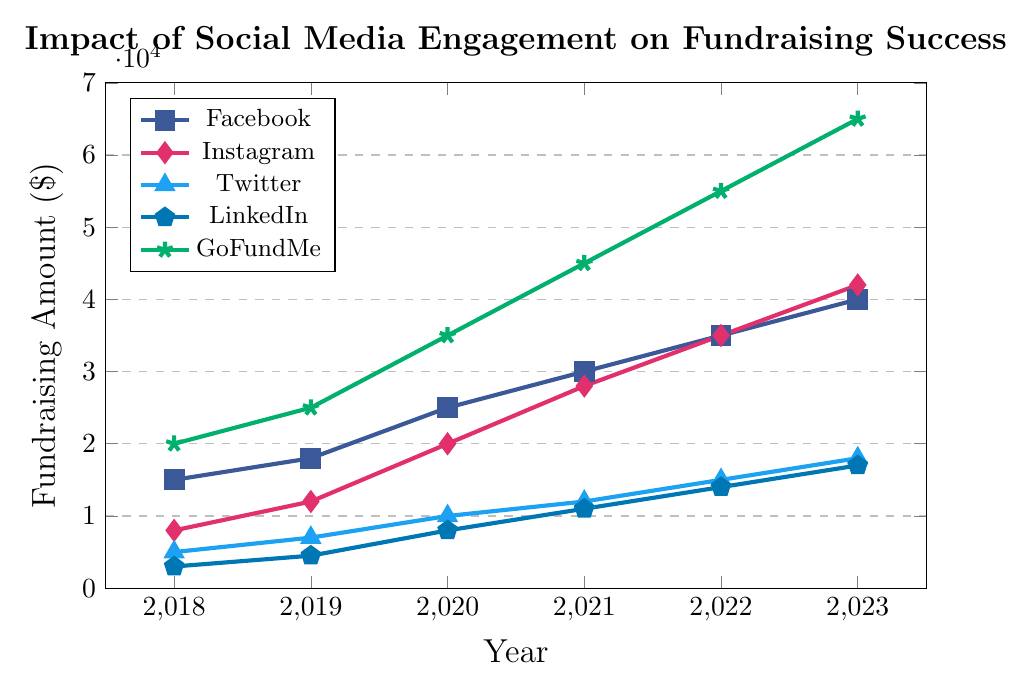what was the amount raised through Twitter in 2020? The data point for Twitter in 2020 indicates a fundraising amount of 10,000. Just locate the year 2020 on the x-axis and read the corresponding value for Twitter.
Answer: 10,000 which platform had the highest fundraising amount in 2023? Look at the data points for all platforms in 2023 and identify the highest value. GoFundMe reached 65,000 in 2023, which is the highest among all platforms.
Answer: GoFundMe what is the total amount raised by Facebook from 2018 to 2023? Sum the Facebook data points for each year: 15,000 (2018) + 18,000 (2019) + 25,000 (2020) + 30,000 (2021) + 35,000 (2022) + 40,000 (2023). The total is 163,000.
Answer: 163,000 how did the fundraising amount by LinkedIn change from 2021 to 2023? Check the LinkedIn data points for 2021 (11,000) and for 2023 (17,000). Subtract 11,000 from 17,000 to find the change. LinkedIn's amount increased by 6,000.
Answer: Increased by 6,000 which platform showed the most significant increase in fundraising amount between 2018 and 2023? Calculate the difference for each platform between their 2018 and 2023 data points. Facebook: 40,000-15,000=25,000; Instagram: 42,000-8,000=34,000; Twitter: 18,000-5,000=13,000; LinkedIn: 17,000-3,000=14,000; GoFundMe: 65,000-20,000=45,000. GoFundMe had the largest increase of 45,000.
Answer: GoFundMe in which year did Instagram surpass Facebook in terms of fundraising amount? Check the data points for Instagram and Facebook each year. In 2022, Instagram (35,000) equals Facebook (35,000), and in 2023, Instagram (42,000) surpasses Facebook (40,000). So, Instagram surpassed Facebook in 2023.
Answer: 2023 what is the average annual fundraising amount for GoFundMe from 2018 to 2023? Sum GoFundMe values from 2018 to 2023 and divide by the number of years: (20,000 + 25,000 + 35,000 + 45,000 + 55,000 + 65,000) / 6 = 245,000 / 6 ≈ 40,833.33.
Answer: 40,833.33 which platform had the least variance in fundraising amount over the years? Look at the changes in data points over the years for trends in fluctuations. Twitter's data points (5,000 to 18,000) show the least dramatic changes compared to other platforms.
Answer: Twitter what was the combined fundraising amount for all platforms in 2020? Sum the amounts for all platforms in 2020: Facebook (25,000) + Instagram (20,000) + Twitter (10,000) + LinkedIn (8,000) + GoFundMe (35,000). The total is 98,000.
Answer: 98,000 which two platforms had the closest fundraising amounts in 2021? Look at the 2021 data points: Facebook (30,000), Instagram (28,000), Twitter (12,000), LinkedIn (11,000), GoFundMe (45,000). Facebook and Instagram are closest with values of 30,000 and 28,000 respectively.
Answer: Facebook and Instagram 